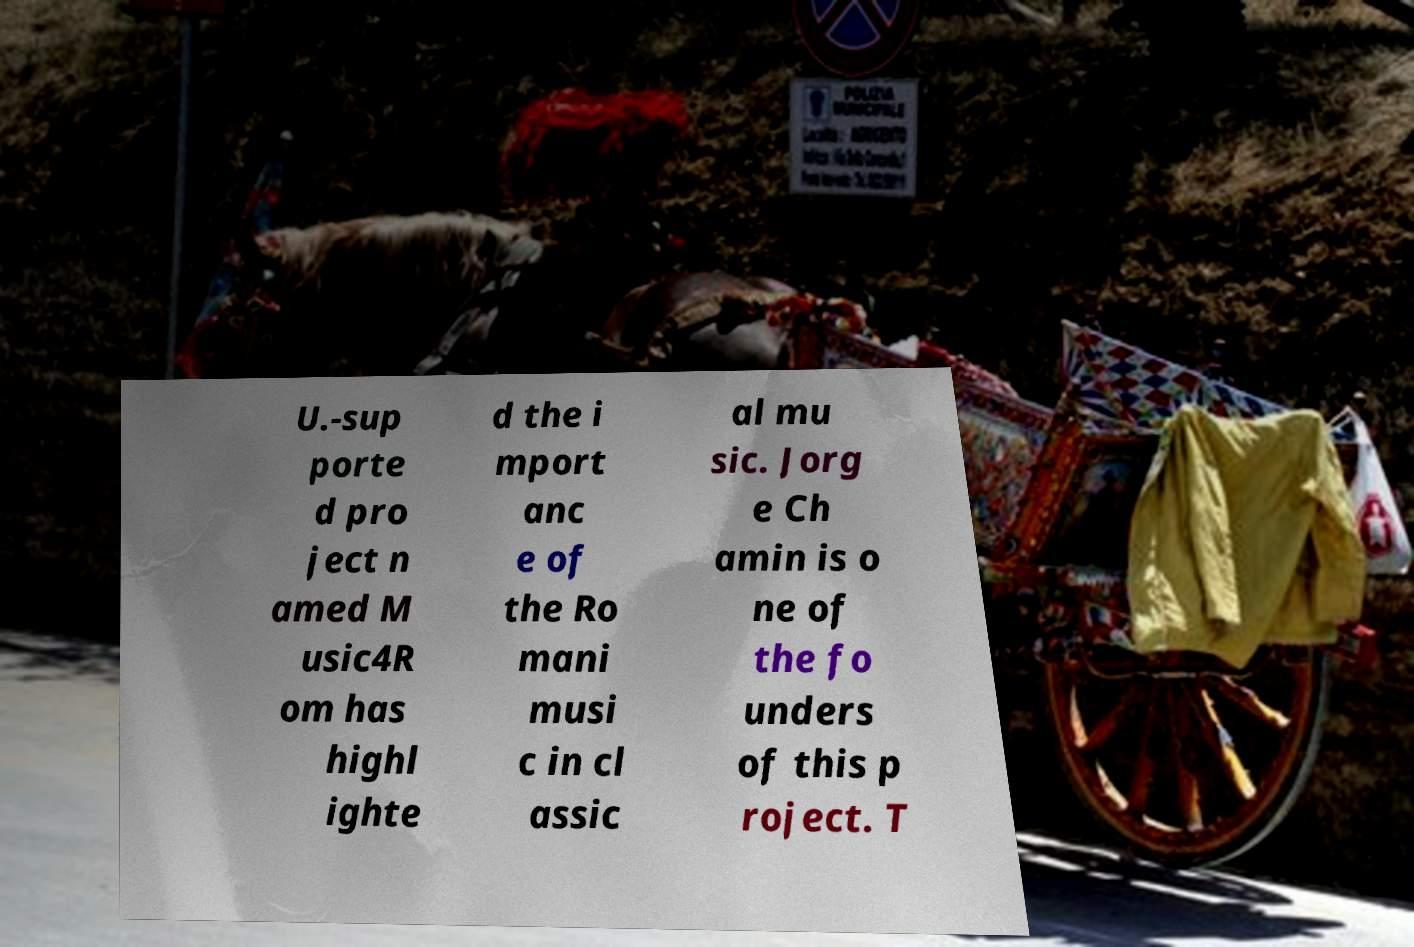Please identify and transcribe the text found in this image. U.-sup porte d pro ject n amed M usic4R om has highl ighte d the i mport anc e of the Ro mani musi c in cl assic al mu sic. Jorg e Ch amin is o ne of the fo unders of this p roject. T 